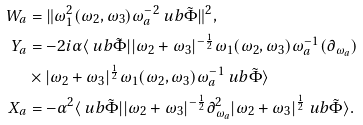<formula> <loc_0><loc_0><loc_500><loc_500>W _ { a } & = \| \omega _ { 1 } ^ { 2 } ( { \omega } _ { 2 } , { \omega } _ { 3 } ) { \omega } _ { a } ^ { - 2 } \ u b { \tilde { \Phi } } \| ^ { 2 } , \\ Y _ { a } & = - 2 i \alpha \langle \ u b { \tilde { \Phi } } | | \omega _ { 2 } + \omega _ { 3 } | ^ { - \frac { 1 } { 2 } } \omega _ { 1 } ( { \omega } _ { 2 } , { \omega } _ { 3 } ) { \omega } _ { a } ^ { - 1 } ( \partial _ { \omega _ { a } } ) \\ & \times | \omega _ { 2 } + \omega _ { 3 } | ^ { \frac { 1 } { 2 } } \omega _ { 1 } ( { \omega } _ { 2 } , { \omega } _ { 3 } ) { \omega } _ { a } ^ { - 1 } \ u b { \tilde { \Phi } } \rangle \\ X _ { a } & = - \alpha ^ { 2 } \langle \ u b { \tilde { \Phi } } | | \omega _ { 2 } + \omega _ { 3 } | ^ { - \frac { 1 } { 2 } } \partial _ { \omega _ { a } } ^ { 2 } | \omega _ { 2 } + \omega _ { 3 } | ^ { \frac { 1 } { 2 } } \ u b { \tilde { \Phi } } \rangle .</formula> 